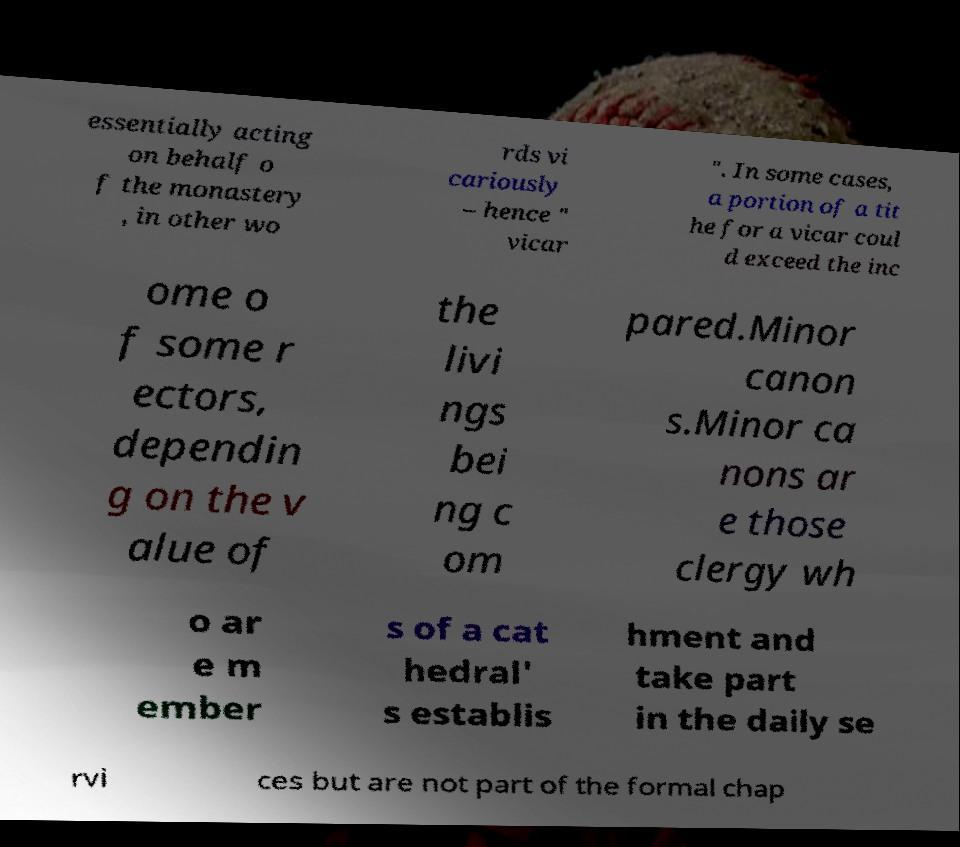What messages or text are displayed in this image? I need them in a readable, typed format. essentially acting on behalf o f the monastery , in other wo rds vi cariously – hence " vicar ". In some cases, a portion of a tit he for a vicar coul d exceed the inc ome o f some r ectors, dependin g on the v alue of the livi ngs bei ng c om pared.Minor canon s.Minor ca nons ar e those clergy wh o ar e m ember s of a cat hedral' s establis hment and take part in the daily se rvi ces but are not part of the formal chap 